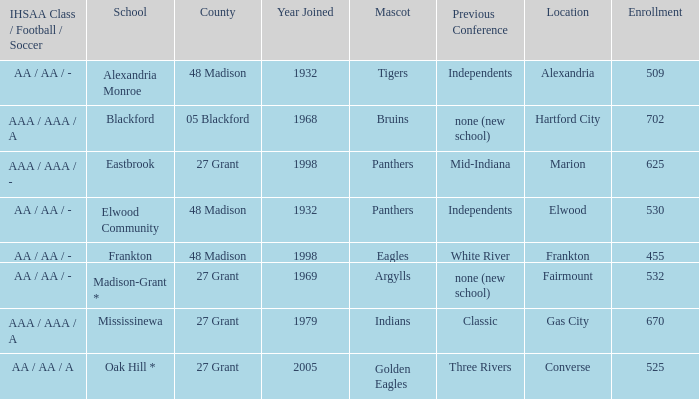I'm looking to parse the entire table for insights. Could you assist me with that? {'header': ['IHSAA Class / Football / Soccer', 'School', 'County', 'Year Joined', 'Mascot', 'Previous Conference', 'Location', 'Enrollment'], 'rows': [['AA / AA / -', 'Alexandria Monroe', '48 Madison', '1932', 'Tigers', 'Independents', 'Alexandria', '509'], ['AAA / AAA / A', 'Blackford', '05 Blackford', '1968', 'Bruins', 'none (new school)', 'Hartford City', '702'], ['AAA / AAA / -', 'Eastbrook', '27 Grant', '1998', 'Panthers', 'Mid-Indiana', 'Marion', '625'], ['AA / AA / -', 'Elwood Community', '48 Madison', '1932', 'Panthers', 'Independents', 'Elwood', '530'], ['AA / AA / -', 'Frankton', '48 Madison', '1998', 'Eagles', 'White River', 'Frankton', '455'], ['AA / AA / -', 'Madison-Grant *', '27 Grant', '1969', 'Argylls', 'none (new school)', 'Fairmount', '532'], ['AAA / AAA / A', 'Mississinewa', '27 Grant', '1979', 'Indians', 'Classic', 'Gas City', '670'], ['AA / AA / A', 'Oak Hill *', '27 Grant', '2005', 'Golden Eagles', 'Three Rivers', 'Converse', '525']]} What is the previous conference when the location is converse? Three Rivers. 